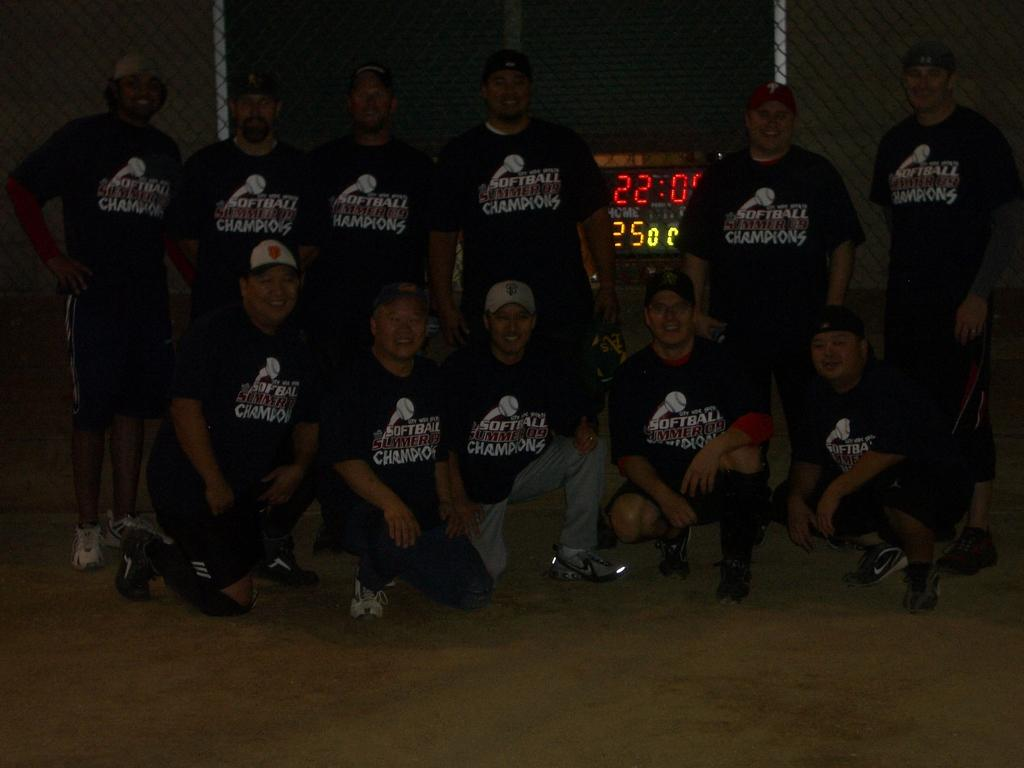<image>
Summarize the visual content of the image. A clock shows twenty two minutes and is surrounded by people. 